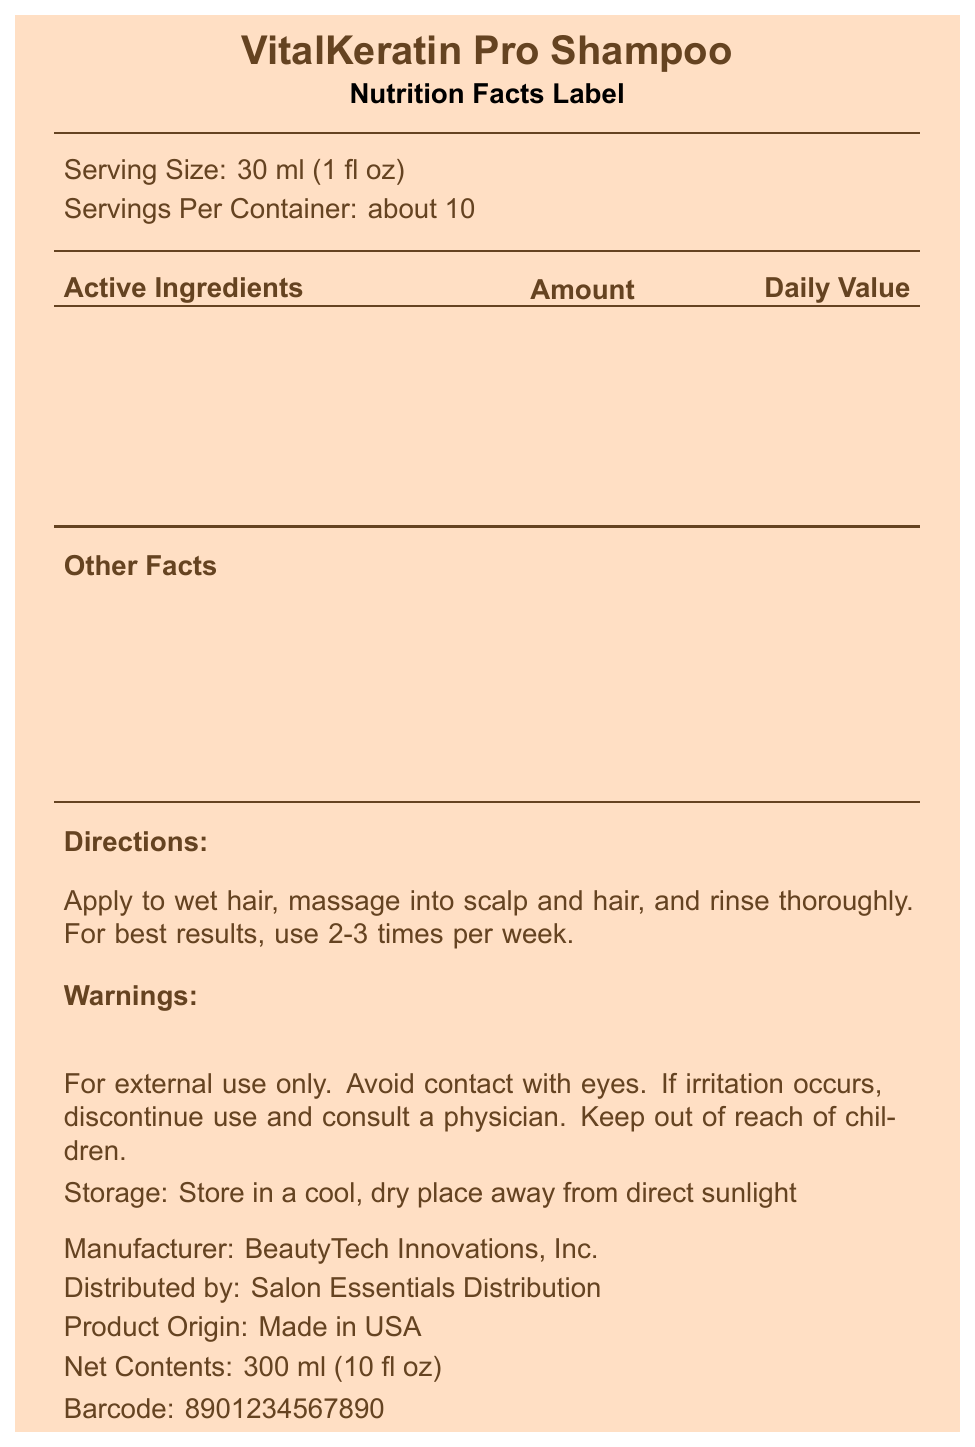what is the serving size of the shampoo? The document lists the serving size as 30 ml (1 fl oz).
Answer: 30 ml (1 fl oz) how many servings are in one container? The document states that there are about 10 servings per container.
Answer: about 10 name an ingredient that provides Vitamin B7 The document lists Biotin (Vitamin B7) as an ingredient.
Answer: Biotin (Vitamin B7) Is the shampoo sulfate-free? The document specifies that the shampoo is not sulfate-free.
Answer: No how much Hydrolyzed Keratin is in a serving? The document lists 2.5 g of Hydrolyzed Keratin per serving.
Answer: 2.5 g which of the following ingredients contribute to the shampoo being pH-balanced? A. Hydrolyzed Keratin B. Citric Acid C. Fragrance (Parfum) Citric Acid is known to help in balancing pH levels in products.
Answer: B what is the daily value percentage of Niacinamide (Vitamin B3)? A. 20% B. 25% C. 31% D. 33% The document lists the daily value of Niacinamide (Vitamin B3) as 31%.
Answer: C is the shampoo paraben-free? The document indicates that the shampoo is paraben-free.
Answer: Yes summarize the main details provided in the Nutrition Facts Label The document provides comprehensive information on the ingredients, active vitamins, serving size, usage directions, and additional product features like being paraben-free and cruelty-free.
Answer: VitalKeratin Pro Shampoo contains hydrolyzed keratin and vitamins B5, B7, E, and B3. It is not sulfate-free but is paraben-free and cruelty-free. The serving size is 30 ml, with about 10 servings per container. The instructions and warnings for use are provided, along with storage information. what is the manufacturing company of VitalKeratin Pro Shampoo? The document lists BeautyTech Innovations, Inc. as the manufacturer.
Answer: BeautyTech Innovations, Inc. how often should the shampoo be used for best results? The document advises using the shampoo 2-3 times per week for best results.
Answer: 2-3 times per week what is the name of the distributing company? The document states that Salon Essentials Distribution is the distributing company.
Answer: Salon Essentials Distribution Is this product made in the USA? The document indicates that the product is made in the USA.
Answer: Yes what is the recommended storage condition for this shampoo? The document advises storing the shampoo in a cool, dry place away from direct sunlight.
Answer: Store in a cool, dry place away from direct sunlight does the document mention the shelf life of the product? The document does not provide any information regarding the shelf life of the product.
Answer: Cannot be determined 